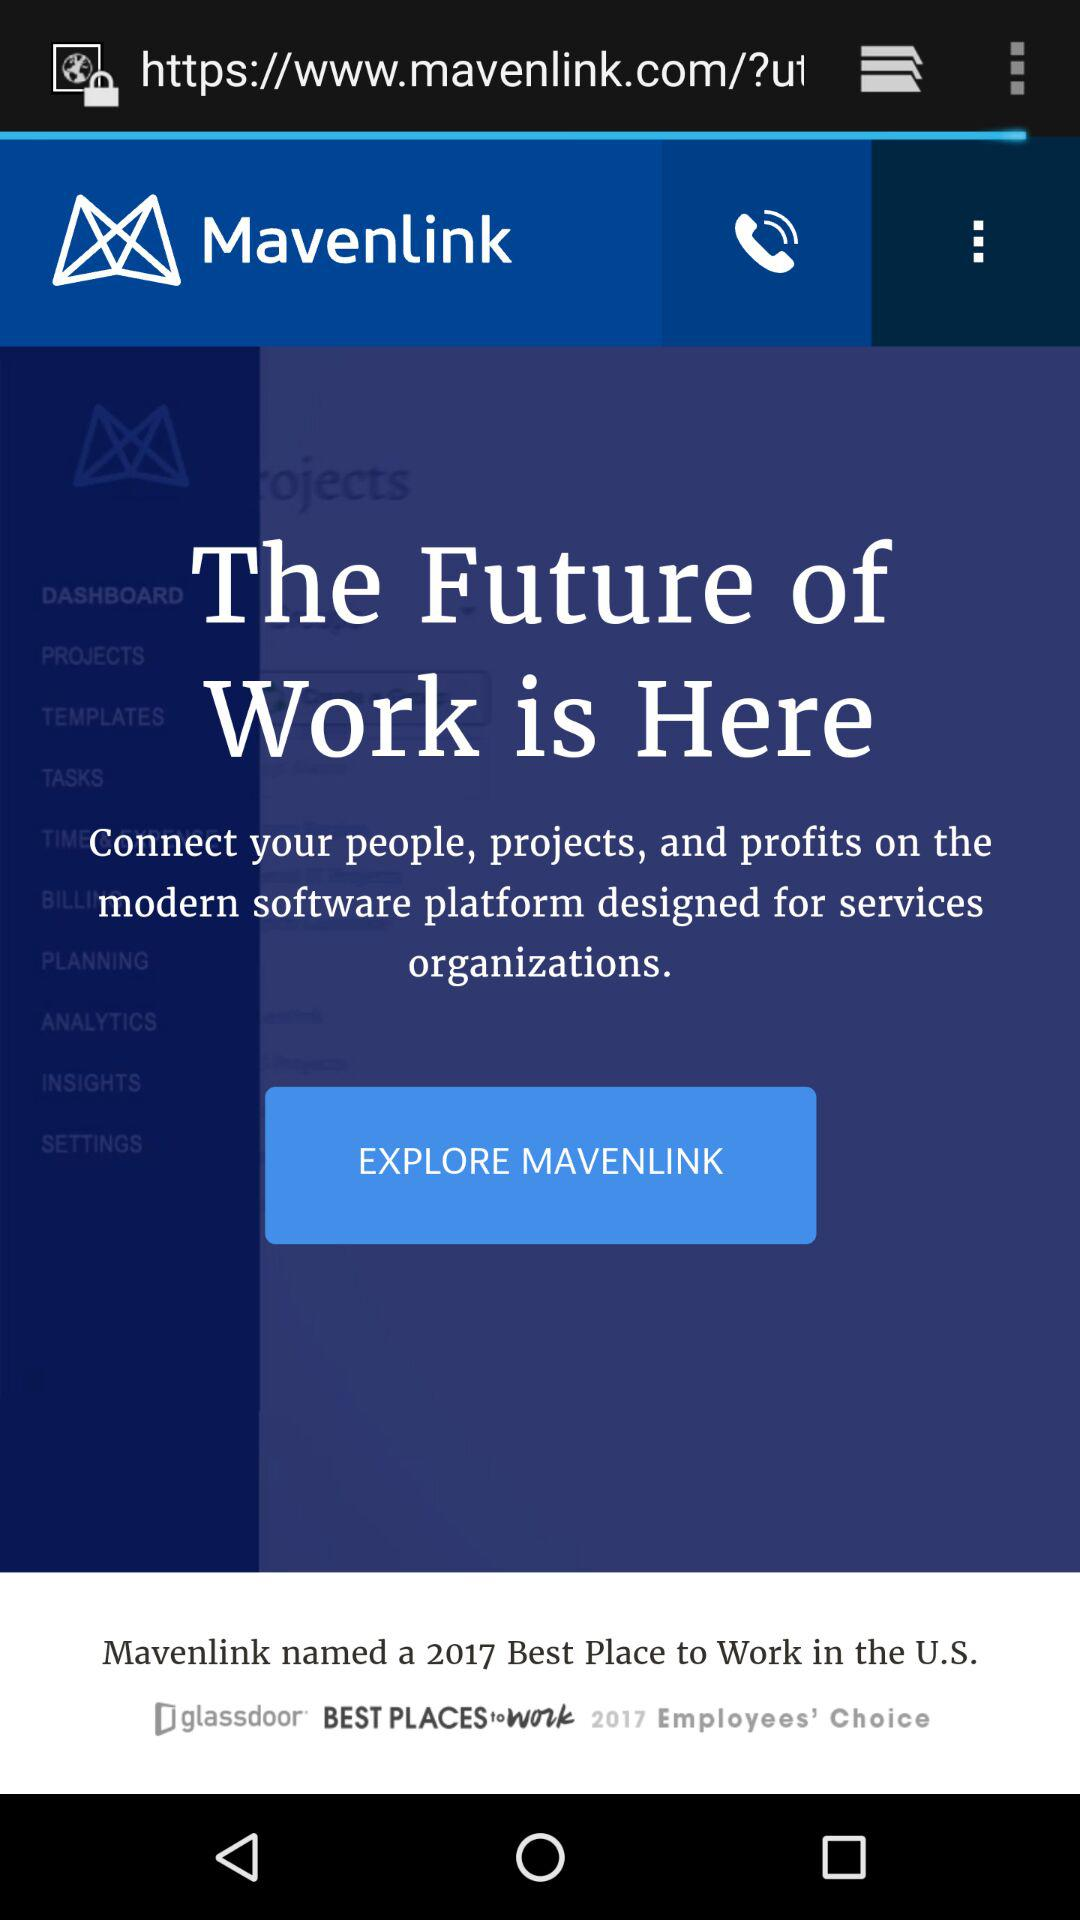What is the tagline? The tagline is "The Future of Work is Here". 